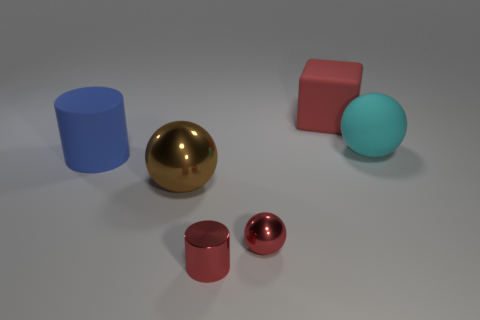Do the large brown object and the cyan rubber thing have the same shape?
Provide a short and direct response. Yes. Is the number of red shiny spheres that are right of the cyan rubber ball the same as the number of brown metal balls that are behind the brown metal thing?
Offer a very short reply. Yes. How many other objects are the same material as the big cylinder?
Your answer should be very brief. 2. How many large things are purple rubber cubes or metal cylinders?
Give a very brief answer. 0. Are there the same number of matte blocks left of the red cube and small gray balls?
Keep it short and to the point. Yes. Is there a tiny metallic ball that is left of the blue matte cylinder in front of the cyan matte sphere?
Keep it short and to the point. No. What number of other objects are the same color as the big metal thing?
Keep it short and to the point. 0. The matte cylinder is what color?
Give a very brief answer. Blue. What is the size of the matte object that is in front of the red matte object and behind the blue rubber cylinder?
Make the answer very short. Large. How many objects are large rubber objects that are left of the big metallic object or brown metal balls?
Keep it short and to the point. 2. 